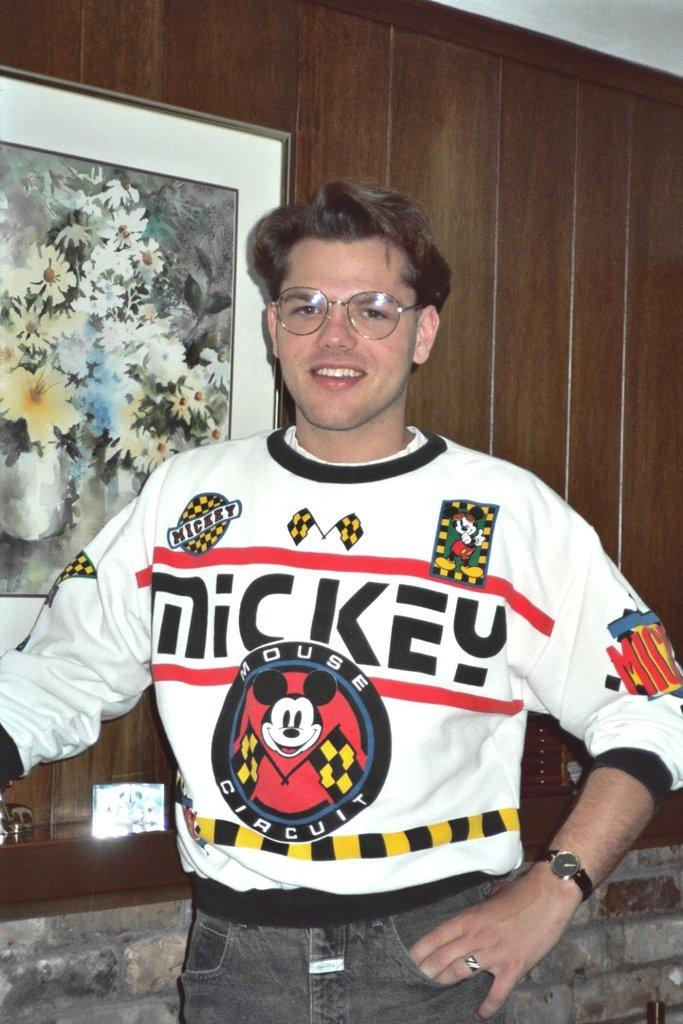<image>
Present a compact description of the photo's key features. A man wearing a shirt with mickey mouse on the front 